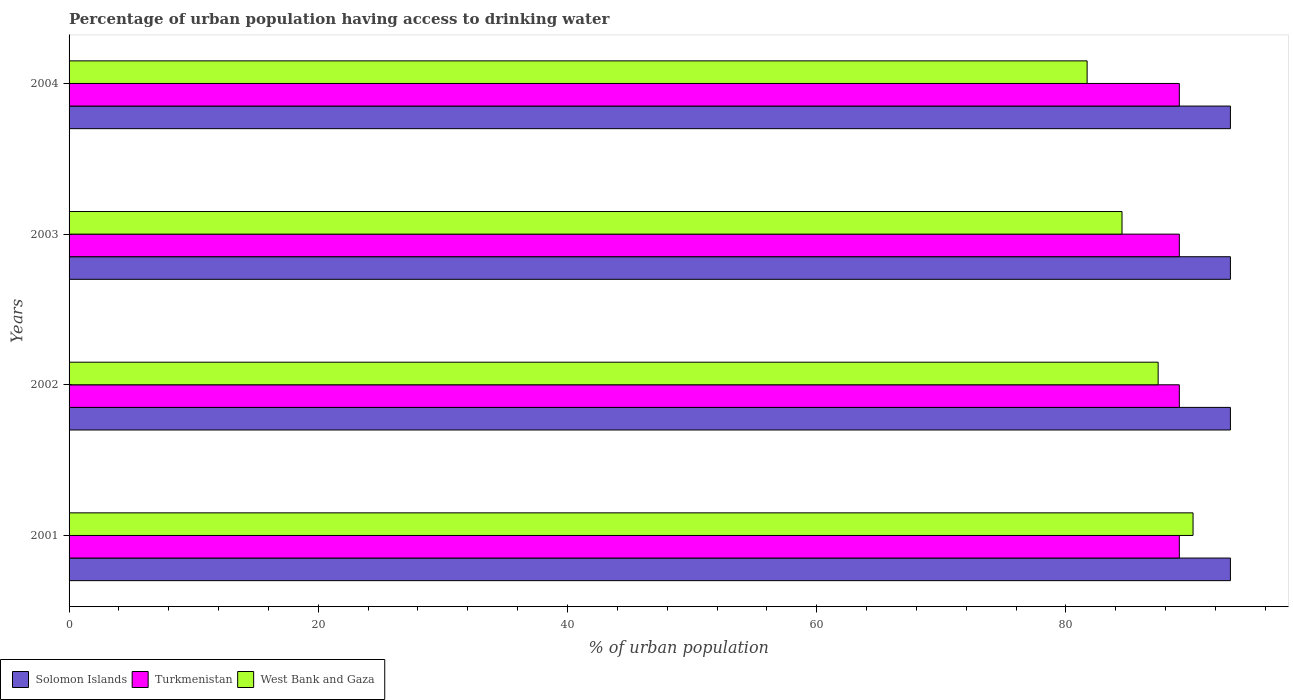How many different coloured bars are there?
Keep it short and to the point. 3. How many groups of bars are there?
Give a very brief answer. 4. Are the number of bars per tick equal to the number of legend labels?
Offer a very short reply. Yes. Are the number of bars on each tick of the Y-axis equal?
Keep it short and to the point. Yes. How many bars are there on the 4th tick from the top?
Provide a short and direct response. 3. How many bars are there on the 2nd tick from the bottom?
Offer a very short reply. 3. In how many cases, is the number of bars for a given year not equal to the number of legend labels?
Your answer should be compact. 0. What is the percentage of urban population having access to drinking water in West Bank and Gaza in 2001?
Your answer should be compact. 90.2. Across all years, what is the maximum percentage of urban population having access to drinking water in Turkmenistan?
Your answer should be compact. 89.1. Across all years, what is the minimum percentage of urban population having access to drinking water in Turkmenistan?
Provide a succinct answer. 89.1. What is the total percentage of urban population having access to drinking water in Turkmenistan in the graph?
Offer a very short reply. 356.4. What is the difference between the percentage of urban population having access to drinking water in West Bank and Gaza in 2004 and the percentage of urban population having access to drinking water in Solomon Islands in 2002?
Provide a short and direct response. -11.5. What is the average percentage of urban population having access to drinking water in Turkmenistan per year?
Ensure brevity in your answer.  89.1. In the year 2002, what is the difference between the percentage of urban population having access to drinking water in West Bank and Gaza and percentage of urban population having access to drinking water in Solomon Islands?
Make the answer very short. -5.8. What is the ratio of the percentage of urban population having access to drinking water in Solomon Islands in 2002 to that in 2004?
Provide a short and direct response. 1. Is the percentage of urban population having access to drinking water in West Bank and Gaza in 2001 less than that in 2003?
Your answer should be compact. No. Is the difference between the percentage of urban population having access to drinking water in West Bank and Gaza in 2001 and 2002 greater than the difference between the percentage of urban population having access to drinking water in Solomon Islands in 2001 and 2002?
Your answer should be compact. Yes. What is the difference between the highest and the lowest percentage of urban population having access to drinking water in Turkmenistan?
Your response must be concise. 0. In how many years, is the percentage of urban population having access to drinking water in Solomon Islands greater than the average percentage of urban population having access to drinking water in Solomon Islands taken over all years?
Your answer should be very brief. 0. What does the 1st bar from the top in 2001 represents?
Keep it short and to the point. West Bank and Gaza. What does the 1st bar from the bottom in 2004 represents?
Give a very brief answer. Solomon Islands. Is it the case that in every year, the sum of the percentage of urban population having access to drinking water in West Bank and Gaza and percentage of urban population having access to drinking water in Solomon Islands is greater than the percentage of urban population having access to drinking water in Turkmenistan?
Provide a succinct answer. Yes. How many years are there in the graph?
Offer a very short reply. 4. Does the graph contain any zero values?
Keep it short and to the point. No. Where does the legend appear in the graph?
Offer a very short reply. Bottom left. How many legend labels are there?
Offer a terse response. 3. How are the legend labels stacked?
Offer a very short reply. Horizontal. What is the title of the graph?
Offer a very short reply. Percentage of urban population having access to drinking water. What is the label or title of the X-axis?
Make the answer very short. % of urban population. What is the % of urban population of Solomon Islands in 2001?
Offer a terse response. 93.2. What is the % of urban population of Turkmenistan in 2001?
Offer a terse response. 89.1. What is the % of urban population of West Bank and Gaza in 2001?
Give a very brief answer. 90.2. What is the % of urban population in Solomon Islands in 2002?
Provide a short and direct response. 93.2. What is the % of urban population in Turkmenistan in 2002?
Your answer should be very brief. 89.1. What is the % of urban population of West Bank and Gaza in 2002?
Your answer should be very brief. 87.4. What is the % of urban population in Solomon Islands in 2003?
Provide a short and direct response. 93.2. What is the % of urban population in Turkmenistan in 2003?
Offer a terse response. 89.1. What is the % of urban population in West Bank and Gaza in 2003?
Provide a short and direct response. 84.5. What is the % of urban population in Solomon Islands in 2004?
Make the answer very short. 93.2. What is the % of urban population of Turkmenistan in 2004?
Offer a terse response. 89.1. What is the % of urban population of West Bank and Gaza in 2004?
Keep it short and to the point. 81.7. Across all years, what is the maximum % of urban population in Solomon Islands?
Provide a short and direct response. 93.2. Across all years, what is the maximum % of urban population in Turkmenistan?
Keep it short and to the point. 89.1. Across all years, what is the maximum % of urban population of West Bank and Gaza?
Make the answer very short. 90.2. Across all years, what is the minimum % of urban population in Solomon Islands?
Provide a succinct answer. 93.2. Across all years, what is the minimum % of urban population in Turkmenistan?
Offer a terse response. 89.1. Across all years, what is the minimum % of urban population of West Bank and Gaza?
Ensure brevity in your answer.  81.7. What is the total % of urban population of Solomon Islands in the graph?
Offer a very short reply. 372.8. What is the total % of urban population in Turkmenistan in the graph?
Provide a succinct answer. 356.4. What is the total % of urban population in West Bank and Gaza in the graph?
Offer a terse response. 343.8. What is the difference between the % of urban population of Turkmenistan in 2001 and that in 2002?
Your answer should be compact. 0. What is the difference between the % of urban population of Turkmenistan in 2001 and that in 2003?
Offer a very short reply. 0. What is the difference between the % of urban population of Solomon Islands in 2001 and that in 2004?
Make the answer very short. 0. What is the difference between the % of urban population in Turkmenistan in 2001 and that in 2004?
Ensure brevity in your answer.  0. What is the difference between the % of urban population of West Bank and Gaza in 2002 and that in 2003?
Make the answer very short. 2.9. What is the difference between the % of urban population in Solomon Islands in 2002 and that in 2004?
Offer a terse response. 0. What is the difference between the % of urban population in Solomon Islands in 2003 and that in 2004?
Your response must be concise. 0. What is the difference between the % of urban population in Solomon Islands in 2001 and the % of urban population in Turkmenistan in 2002?
Give a very brief answer. 4.1. What is the difference between the % of urban population in Turkmenistan in 2001 and the % of urban population in West Bank and Gaza in 2002?
Provide a short and direct response. 1.7. What is the difference between the % of urban population of Solomon Islands in 2001 and the % of urban population of Turkmenistan in 2003?
Give a very brief answer. 4.1. What is the difference between the % of urban population in Solomon Islands in 2001 and the % of urban population in West Bank and Gaza in 2003?
Offer a terse response. 8.7. What is the difference between the % of urban population in Turkmenistan in 2001 and the % of urban population in West Bank and Gaza in 2003?
Your response must be concise. 4.6. What is the difference between the % of urban population in Solomon Islands in 2002 and the % of urban population in Turkmenistan in 2003?
Provide a short and direct response. 4.1. What is the difference between the % of urban population in Solomon Islands in 2002 and the % of urban population in West Bank and Gaza in 2003?
Your response must be concise. 8.7. What is the difference between the % of urban population in Solomon Islands in 2002 and the % of urban population in West Bank and Gaza in 2004?
Ensure brevity in your answer.  11.5. What is the average % of urban population of Solomon Islands per year?
Your answer should be compact. 93.2. What is the average % of urban population of Turkmenistan per year?
Keep it short and to the point. 89.1. What is the average % of urban population in West Bank and Gaza per year?
Make the answer very short. 85.95. In the year 2001, what is the difference between the % of urban population in Solomon Islands and % of urban population in Turkmenistan?
Ensure brevity in your answer.  4.1. In the year 2001, what is the difference between the % of urban population of Turkmenistan and % of urban population of West Bank and Gaza?
Ensure brevity in your answer.  -1.1. In the year 2002, what is the difference between the % of urban population of Solomon Islands and % of urban population of Turkmenistan?
Give a very brief answer. 4.1. In the year 2002, what is the difference between the % of urban population of Solomon Islands and % of urban population of West Bank and Gaza?
Your response must be concise. 5.8. In the year 2003, what is the difference between the % of urban population of Solomon Islands and % of urban population of Turkmenistan?
Offer a terse response. 4.1. In the year 2003, what is the difference between the % of urban population of Turkmenistan and % of urban population of West Bank and Gaza?
Provide a short and direct response. 4.6. In the year 2004, what is the difference between the % of urban population in Solomon Islands and % of urban population in West Bank and Gaza?
Keep it short and to the point. 11.5. What is the ratio of the % of urban population of West Bank and Gaza in 2001 to that in 2002?
Your response must be concise. 1.03. What is the ratio of the % of urban population in West Bank and Gaza in 2001 to that in 2003?
Provide a succinct answer. 1.07. What is the ratio of the % of urban population of Solomon Islands in 2001 to that in 2004?
Ensure brevity in your answer.  1. What is the ratio of the % of urban population in Turkmenistan in 2001 to that in 2004?
Provide a short and direct response. 1. What is the ratio of the % of urban population in West Bank and Gaza in 2001 to that in 2004?
Keep it short and to the point. 1.1. What is the ratio of the % of urban population of Solomon Islands in 2002 to that in 2003?
Offer a very short reply. 1. What is the ratio of the % of urban population of West Bank and Gaza in 2002 to that in 2003?
Your response must be concise. 1.03. What is the ratio of the % of urban population in West Bank and Gaza in 2002 to that in 2004?
Give a very brief answer. 1.07. What is the ratio of the % of urban population in Turkmenistan in 2003 to that in 2004?
Offer a very short reply. 1. What is the ratio of the % of urban population in West Bank and Gaza in 2003 to that in 2004?
Offer a terse response. 1.03. What is the difference between the highest and the second highest % of urban population in West Bank and Gaza?
Provide a succinct answer. 2.8. What is the difference between the highest and the lowest % of urban population of Solomon Islands?
Keep it short and to the point. 0. What is the difference between the highest and the lowest % of urban population of Turkmenistan?
Your response must be concise. 0. 